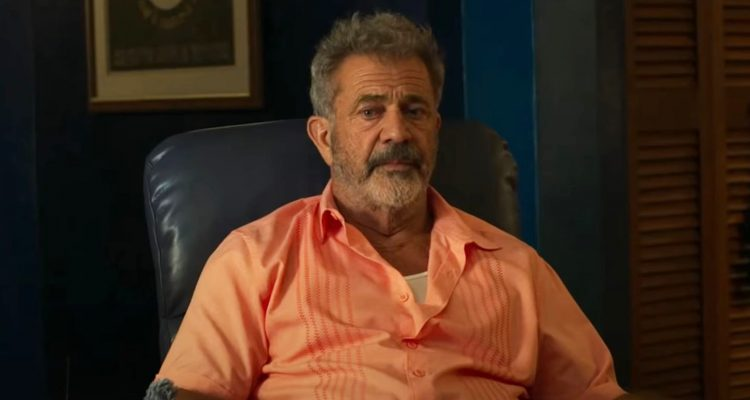Describe the setting in the image in vivid detail. The setting in the image is a cozy, yet professional-looking office space. Dominating the scene is a plush, blue leather chair where the character is seated. He’s dressed in a light salmon-colored shirt, which contrasts gently against the deep blue walls. One of the walls holds a distinguished framed certificate, adding a touch of academic or professional accomplishment to the atmosphere. To the side is a wooden shelf filled with books, possibly indicating the character’s scholarly interests or a background in education. The lighting is soft, creating a warm and contemplative ambiance. Adding to the room’s texture are a set of louvered wooden doors, which hint at other areas of the space, perhaps rooms filled with more books or memories. Imagine this room during the night. How does it change? At night, the room takes on a more serene and intimate atmosphere. Soft, warm lighting from a desk lamp or wall sconce casts gentle shadows, making the blue of the walls appear deeper and more muted. The framed certificate gleams subtly, a silent testament to past achievements. The wooden bookshelf, now partially obscured in the dim light, adds a touch of rustic charm, with the spines of books barely visible. The blue leather chair looks even more inviting, a perfect spot for late-night musings or quiet reading sessions. The louvered doors close, offering a cozy cocoon-like feel to the room, isolating it from the rest of the house and creating an ideal retreat for thoughtful contemplation or creative inspiration. 